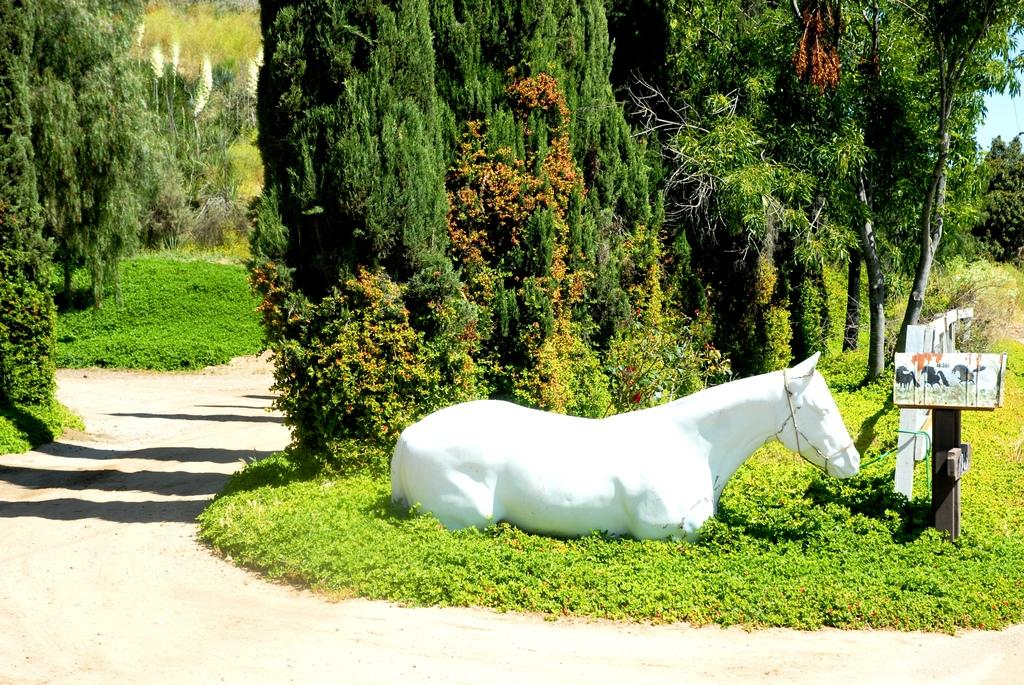What is the main object in the image? There is a statue in the image. What is located near the statue? There is a signboard and a fence in the image. What type of vegetation can be seen in the image? There is grass and a group of trees in the image. What part of the natural environment is visible in the image? The sky is visible in the image. What type of lead can be seen in the image? There is no lead present in the image. Is there a bear visible in the image? No, there is no bear present in the image. 